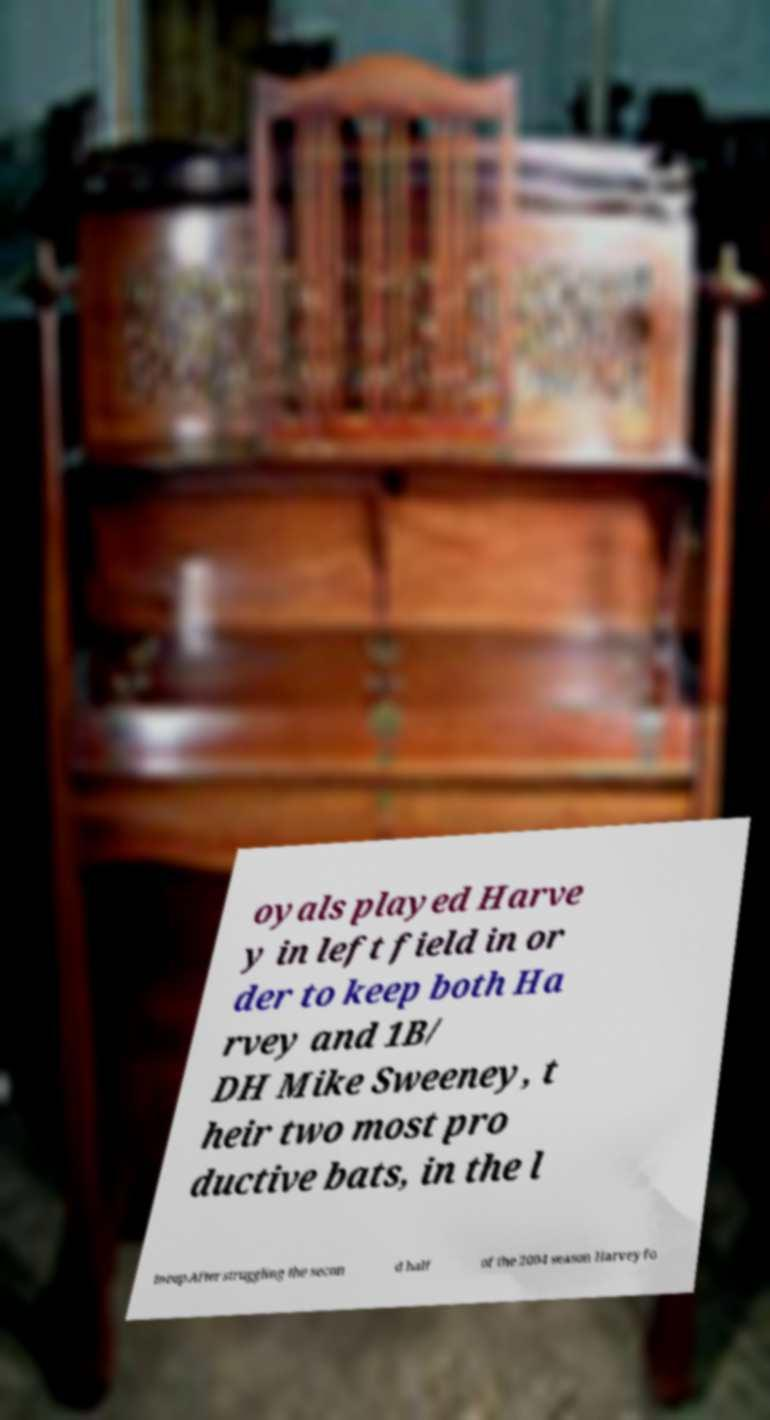Please identify and transcribe the text found in this image. oyals played Harve y in left field in or der to keep both Ha rvey and 1B/ DH Mike Sweeney, t heir two most pro ductive bats, in the l ineup.After struggling the secon d half of the 2004 season Harvey fo 